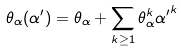<formula> <loc_0><loc_0><loc_500><loc_500>\theta _ { \alpha } ( { \alpha ^ { \prime } } ) = \theta _ { \alpha } + \sum _ { k \geq 1 } \theta ^ { k } _ { \alpha } { \alpha ^ { \prime } } ^ { k }</formula> 